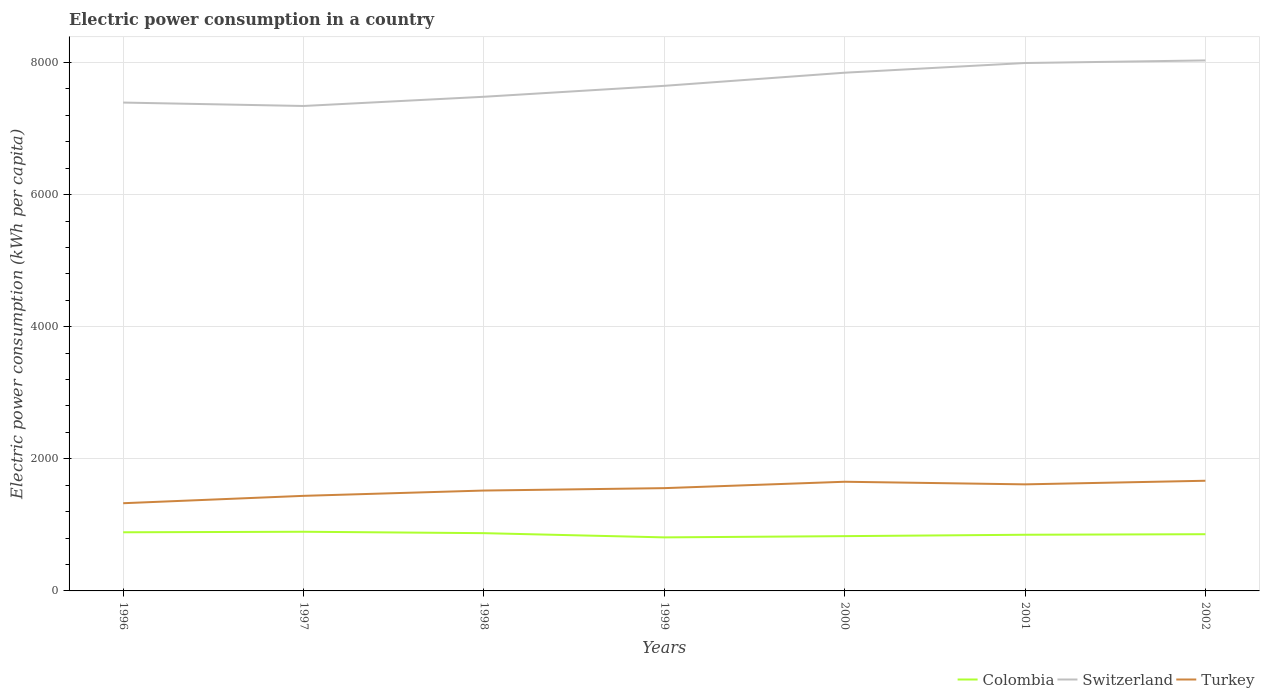How many different coloured lines are there?
Your answer should be compact. 3. Is the number of lines equal to the number of legend labels?
Your answer should be very brief. Yes. Across all years, what is the maximum electric power consumption in in Switzerland?
Provide a short and direct response. 7341.75. In which year was the electric power consumption in in Colombia maximum?
Provide a succinct answer. 1999. What is the total electric power consumption in in Switzerland in the graph?
Your response must be concise. -650.52. What is the difference between the highest and the second highest electric power consumption in in Colombia?
Provide a succinct answer. 85.18. What is the difference between the highest and the lowest electric power consumption in in Switzerland?
Your response must be concise. 3. How many lines are there?
Make the answer very short. 3. Are the values on the major ticks of Y-axis written in scientific E-notation?
Your answer should be very brief. No. How are the legend labels stacked?
Provide a succinct answer. Horizontal. What is the title of the graph?
Provide a succinct answer. Electric power consumption in a country. What is the label or title of the Y-axis?
Make the answer very short. Electric power consumption (kWh per capita). What is the Electric power consumption (kWh per capita) of Colombia in 1996?
Your response must be concise. 887.8. What is the Electric power consumption (kWh per capita) of Switzerland in 1996?
Make the answer very short. 7393.54. What is the Electric power consumption (kWh per capita) of Turkey in 1996?
Provide a succinct answer. 1327.72. What is the Electric power consumption (kWh per capita) of Colombia in 1997?
Make the answer very short. 895.86. What is the Electric power consumption (kWh per capita) of Switzerland in 1997?
Offer a very short reply. 7341.75. What is the Electric power consumption (kWh per capita) of Turkey in 1997?
Your answer should be very brief. 1439.46. What is the Electric power consumption (kWh per capita) in Colombia in 1998?
Your answer should be very brief. 874.44. What is the Electric power consumption (kWh per capita) of Switzerland in 1998?
Keep it short and to the point. 7481.29. What is the Electric power consumption (kWh per capita) of Turkey in 1998?
Your response must be concise. 1519.72. What is the Electric power consumption (kWh per capita) of Colombia in 1999?
Your answer should be very brief. 810.69. What is the Electric power consumption (kWh per capita) in Switzerland in 1999?
Provide a succinct answer. 7646.85. What is the Electric power consumption (kWh per capita) in Turkey in 1999?
Your answer should be compact. 1556.13. What is the Electric power consumption (kWh per capita) in Colombia in 2000?
Make the answer very short. 829.4. What is the Electric power consumption (kWh per capita) in Switzerland in 2000?
Ensure brevity in your answer.  7845.5. What is the Electric power consumption (kWh per capita) of Turkey in 2000?
Provide a short and direct response. 1652.75. What is the Electric power consumption (kWh per capita) of Colombia in 2001?
Make the answer very short. 850.43. What is the Electric power consumption (kWh per capita) in Switzerland in 2001?
Provide a succinct answer. 7992.28. What is the Electric power consumption (kWh per capita) of Turkey in 2001?
Keep it short and to the point. 1613.24. What is the Electric power consumption (kWh per capita) in Colombia in 2002?
Make the answer very short. 858.62. What is the Electric power consumption (kWh per capita) in Switzerland in 2002?
Provide a succinct answer. 8031.43. What is the Electric power consumption (kWh per capita) in Turkey in 2002?
Give a very brief answer. 1667.87. Across all years, what is the maximum Electric power consumption (kWh per capita) in Colombia?
Make the answer very short. 895.86. Across all years, what is the maximum Electric power consumption (kWh per capita) in Switzerland?
Keep it short and to the point. 8031.43. Across all years, what is the maximum Electric power consumption (kWh per capita) in Turkey?
Offer a terse response. 1667.87. Across all years, what is the minimum Electric power consumption (kWh per capita) of Colombia?
Your answer should be compact. 810.69. Across all years, what is the minimum Electric power consumption (kWh per capita) in Switzerland?
Your answer should be very brief. 7341.75. Across all years, what is the minimum Electric power consumption (kWh per capita) in Turkey?
Keep it short and to the point. 1327.72. What is the total Electric power consumption (kWh per capita) in Colombia in the graph?
Make the answer very short. 6007.24. What is the total Electric power consumption (kWh per capita) of Switzerland in the graph?
Your response must be concise. 5.37e+04. What is the total Electric power consumption (kWh per capita) of Turkey in the graph?
Your answer should be compact. 1.08e+04. What is the difference between the Electric power consumption (kWh per capita) of Colombia in 1996 and that in 1997?
Provide a succinct answer. -8.06. What is the difference between the Electric power consumption (kWh per capita) in Switzerland in 1996 and that in 1997?
Your response must be concise. 51.79. What is the difference between the Electric power consumption (kWh per capita) in Turkey in 1996 and that in 1997?
Ensure brevity in your answer.  -111.74. What is the difference between the Electric power consumption (kWh per capita) of Colombia in 1996 and that in 1998?
Give a very brief answer. 13.36. What is the difference between the Electric power consumption (kWh per capita) in Switzerland in 1996 and that in 1998?
Ensure brevity in your answer.  -87.75. What is the difference between the Electric power consumption (kWh per capita) in Turkey in 1996 and that in 1998?
Your answer should be compact. -192. What is the difference between the Electric power consumption (kWh per capita) of Colombia in 1996 and that in 1999?
Give a very brief answer. 77.11. What is the difference between the Electric power consumption (kWh per capita) of Switzerland in 1996 and that in 1999?
Your response must be concise. -253.31. What is the difference between the Electric power consumption (kWh per capita) of Turkey in 1996 and that in 1999?
Offer a very short reply. -228.41. What is the difference between the Electric power consumption (kWh per capita) in Colombia in 1996 and that in 2000?
Your answer should be very brief. 58.4. What is the difference between the Electric power consumption (kWh per capita) of Switzerland in 1996 and that in 2000?
Offer a very short reply. -451.96. What is the difference between the Electric power consumption (kWh per capita) in Turkey in 1996 and that in 2000?
Offer a very short reply. -325.03. What is the difference between the Electric power consumption (kWh per capita) in Colombia in 1996 and that in 2001?
Provide a succinct answer. 37.38. What is the difference between the Electric power consumption (kWh per capita) of Switzerland in 1996 and that in 2001?
Your answer should be very brief. -598.74. What is the difference between the Electric power consumption (kWh per capita) in Turkey in 1996 and that in 2001?
Provide a short and direct response. -285.52. What is the difference between the Electric power consumption (kWh per capita) in Colombia in 1996 and that in 2002?
Offer a very short reply. 29.18. What is the difference between the Electric power consumption (kWh per capita) in Switzerland in 1996 and that in 2002?
Make the answer very short. -637.89. What is the difference between the Electric power consumption (kWh per capita) in Turkey in 1996 and that in 2002?
Provide a short and direct response. -340.14. What is the difference between the Electric power consumption (kWh per capita) of Colombia in 1997 and that in 1998?
Offer a terse response. 21.42. What is the difference between the Electric power consumption (kWh per capita) in Switzerland in 1997 and that in 1998?
Your answer should be very brief. -139.54. What is the difference between the Electric power consumption (kWh per capita) of Turkey in 1997 and that in 1998?
Your answer should be very brief. -80.26. What is the difference between the Electric power consumption (kWh per capita) of Colombia in 1997 and that in 1999?
Your response must be concise. 85.18. What is the difference between the Electric power consumption (kWh per capita) in Switzerland in 1997 and that in 1999?
Provide a short and direct response. -305.09. What is the difference between the Electric power consumption (kWh per capita) of Turkey in 1997 and that in 1999?
Ensure brevity in your answer.  -116.67. What is the difference between the Electric power consumption (kWh per capita) in Colombia in 1997 and that in 2000?
Your answer should be very brief. 66.46. What is the difference between the Electric power consumption (kWh per capita) of Switzerland in 1997 and that in 2000?
Provide a short and direct response. -503.74. What is the difference between the Electric power consumption (kWh per capita) of Turkey in 1997 and that in 2000?
Provide a short and direct response. -213.29. What is the difference between the Electric power consumption (kWh per capita) in Colombia in 1997 and that in 2001?
Offer a very short reply. 45.44. What is the difference between the Electric power consumption (kWh per capita) of Switzerland in 1997 and that in 2001?
Keep it short and to the point. -650.52. What is the difference between the Electric power consumption (kWh per capita) in Turkey in 1997 and that in 2001?
Offer a very short reply. -173.78. What is the difference between the Electric power consumption (kWh per capita) of Colombia in 1997 and that in 2002?
Make the answer very short. 37.24. What is the difference between the Electric power consumption (kWh per capita) in Switzerland in 1997 and that in 2002?
Ensure brevity in your answer.  -689.68. What is the difference between the Electric power consumption (kWh per capita) of Turkey in 1997 and that in 2002?
Make the answer very short. -228.4. What is the difference between the Electric power consumption (kWh per capita) in Colombia in 1998 and that in 1999?
Make the answer very short. 63.76. What is the difference between the Electric power consumption (kWh per capita) in Switzerland in 1998 and that in 1999?
Make the answer very short. -165.55. What is the difference between the Electric power consumption (kWh per capita) in Turkey in 1998 and that in 1999?
Your response must be concise. -36.41. What is the difference between the Electric power consumption (kWh per capita) of Colombia in 1998 and that in 2000?
Give a very brief answer. 45.05. What is the difference between the Electric power consumption (kWh per capita) in Switzerland in 1998 and that in 2000?
Offer a terse response. -364.2. What is the difference between the Electric power consumption (kWh per capita) of Turkey in 1998 and that in 2000?
Your answer should be compact. -133.03. What is the difference between the Electric power consumption (kWh per capita) in Colombia in 1998 and that in 2001?
Keep it short and to the point. 24.02. What is the difference between the Electric power consumption (kWh per capita) of Switzerland in 1998 and that in 2001?
Offer a terse response. -510.98. What is the difference between the Electric power consumption (kWh per capita) in Turkey in 1998 and that in 2001?
Provide a succinct answer. -93.52. What is the difference between the Electric power consumption (kWh per capita) of Colombia in 1998 and that in 2002?
Your answer should be compact. 15.82. What is the difference between the Electric power consumption (kWh per capita) of Switzerland in 1998 and that in 2002?
Your response must be concise. -550.14. What is the difference between the Electric power consumption (kWh per capita) in Turkey in 1998 and that in 2002?
Your answer should be very brief. -148.15. What is the difference between the Electric power consumption (kWh per capita) in Colombia in 1999 and that in 2000?
Provide a short and direct response. -18.71. What is the difference between the Electric power consumption (kWh per capita) of Switzerland in 1999 and that in 2000?
Your answer should be very brief. -198.65. What is the difference between the Electric power consumption (kWh per capita) in Turkey in 1999 and that in 2000?
Give a very brief answer. -96.62. What is the difference between the Electric power consumption (kWh per capita) in Colombia in 1999 and that in 2001?
Provide a succinct answer. -39.74. What is the difference between the Electric power consumption (kWh per capita) of Switzerland in 1999 and that in 2001?
Your answer should be compact. -345.43. What is the difference between the Electric power consumption (kWh per capita) in Turkey in 1999 and that in 2001?
Offer a terse response. -57.11. What is the difference between the Electric power consumption (kWh per capita) in Colombia in 1999 and that in 2002?
Ensure brevity in your answer.  -47.93. What is the difference between the Electric power consumption (kWh per capita) of Switzerland in 1999 and that in 2002?
Make the answer very short. -384.59. What is the difference between the Electric power consumption (kWh per capita) in Turkey in 1999 and that in 2002?
Keep it short and to the point. -111.74. What is the difference between the Electric power consumption (kWh per capita) in Colombia in 2000 and that in 2001?
Give a very brief answer. -21.03. What is the difference between the Electric power consumption (kWh per capita) in Switzerland in 2000 and that in 2001?
Offer a terse response. -146.78. What is the difference between the Electric power consumption (kWh per capita) of Turkey in 2000 and that in 2001?
Offer a terse response. 39.51. What is the difference between the Electric power consumption (kWh per capita) in Colombia in 2000 and that in 2002?
Give a very brief answer. -29.22. What is the difference between the Electric power consumption (kWh per capita) in Switzerland in 2000 and that in 2002?
Keep it short and to the point. -185.94. What is the difference between the Electric power consumption (kWh per capita) of Turkey in 2000 and that in 2002?
Keep it short and to the point. -15.12. What is the difference between the Electric power consumption (kWh per capita) in Colombia in 2001 and that in 2002?
Keep it short and to the point. -8.2. What is the difference between the Electric power consumption (kWh per capita) of Switzerland in 2001 and that in 2002?
Ensure brevity in your answer.  -39.15. What is the difference between the Electric power consumption (kWh per capita) of Turkey in 2001 and that in 2002?
Your answer should be compact. -54.63. What is the difference between the Electric power consumption (kWh per capita) of Colombia in 1996 and the Electric power consumption (kWh per capita) of Switzerland in 1997?
Provide a succinct answer. -6453.95. What is the difference between the Electric power consumption (kWh per capita) of Colombia in 1996 and the Electric power consumption (kWh per capita) of Turkey in 1997?
Your response must be concise. -551.66. What is the difference between the Electric power consumption (kWh per capita) in Switzerland in 1996 and the Electric power consumption (kWh per capita) in Turkey in 1997?
Provide a succinct answer. 5954.08. What is the difference between the Electric power consumption (kWh per capita) in Colombia in 1996 and the Electric power consumption (kWh per capita) in Switzerland in 1998?
Offer a terse response. -6593.49. What is the difference between the Electric power consumption (kWh per capita) of Colombia in 1996 and the Electric power consumption (kWh per capita) of Turkey in 1998?
Give a very brief answer. -631.92. What is the difference between the Electric power consumption (kWh per capita) of Switzerland in 1996 and the Electric power consumption (kWh per capita) of Turkey in 1998?
Your response must be concise. 5873.82. What is the difference between the Electric power consumption (kWh per capita) in Colombia in 1996 and the Electric power consumption (kWh per capita) in Switzerland in 1999?
Provide a short and direct response. -6759.04. What is the difference between the Electric power consumption (kWh per capita) in Colombia in 1996 and the Electric power consumption (kWh per capita) in Turkey in 1999?
Your answer should be compact. -668.33. What is the difference between the Electric power consumption (kWh per capita) in Switzerland in 1996 and the Electric power consumption (kWh per capita) in Turkey in 1999?
Give a very brief answer. 5837.41. What is the difference between the Electric power consumption (kWh per capita) in Colombia in 1996 and the Electric power consumption (kWh per capita) in Switzerland in 2000?
Your answer should be very brief. -6957.69. What is the difference between the Electric power consumption (kWh per capita) in Colombia in 1996 and the Electric power consumption (kWh per capita) in Turkey in 2000?
Provide a succinct answer. -764.95. What is the difference between the Electric power consumption (kWh per capita) of Switzerland in 1996 and the Electric power consumption (kWh per capita) of Turkey in 2000?
Your answer should be very brief. 5740.79. What is the difference between the Electric power consumption (kWh per capita) of Colombia in 1996 and the Electric power consumption (kWh per capita) of Switzerland in 2001?
Give a very brief answer. -7104.48. What is the difference between the Electric power consumption (kWh per capita) in Colombia in 1996 and the Electric power consumption (kWh per capita) in Turkey in 2001?
Keep it short and to the point. -725.44. What is the difference between the Electric power consumption (kWh per capita) in Switzerland in 1996 and the Electric power consumption (kWh per capita) in Turkey in 2001?
Provide a succinct answer. 5780.3. What is the difference between the Electric power consumption (kWh per capita) in Colombia in 1996 and the Electric power consumption (kWh per capita) in Switzerland in 2002?
Provide a short and direct response. -7143.63. What is the difference between the Electric power consumption (kWh per capita) of Colombia in 1996 and the Electric power consumption (kWh per capita) of Turkey in 2002?
Your answer should be compact. -780.06. What is the difference between the Electric power consumption (kWh per capita) of Switzerland in 1996 and the Electric power consumption (kWh per capita) of Turkey in 2002?
Provide a short and direct response. 5725.67. What is the difference between the Electric power consumption (kWh per capita) in Colombia in 1997 and the Electric power consumption (kWh per capita) in Switzerland in 1998?
Keep it short and to the point. -6585.43. What is the difference between the Electric power consumption (kWh per capita) of Colombia in 1997 and the Electric power consumption (kWh per capita) of Turkey in 1998?
Your answer should be compact. -623.86. What is the difference between the Electric power consumption (kWh per capita) of Switzerland in 1997 and the Electric power consumption (kWh per capita) of Turkey in 1998?
Offer a very short reply. 5822.03. What is the difference between the Electric power consumption (kWh per capita) in Colombia in 1997 and the Electric power consumption (kWh per capita) in Switzerland in 1999?
Your answer should be compact. -6750.98. What is the difference between the Electric power consumption (kWh per capita) in Colombia in 1997 and the Electric power consumption (kWh per capita) in Turkey in 1999?
Offer a very short reply. -660.27. What is the difference between the Electric power consumption (kWh per capita) of Switzerland in 1997 and the Electric power consumption (kWh per capita) of Turkey in 1999?
Make the answer very short. 5785.62. What is the difference between the Electric power consumption (kWh per capita) in Colombia in 1997 and the Electric power consumption (kWh per capita) in Switzerland in 2000?
Your answer should be very brief. -6949.63. What is the difference between the Electric power consumption (kWh per capita) in Colombia in 1997 and the Electric power consumption (kWh per capita) in Turkey in 2000?
Offer a very short reply. -756.88. What is the difference between the Electric power consumption (kWh per capita) of Switzerland in 1997 and the Electric power consumption (kWh per capita) of Turkey in 2000?
Keep it short and to the point. 5689.01. What is the difference between the Electric power consumption (kWh per capita) in Colombia in 1997 and the Electric power consumption (kWh per capita) in Switzerland in 2001?
Your answer should be compact. -7096.41. What is the difference between the Electric power consumption (kWh per capita) of Colombia in 1997 and the Electric power consumption (kWh per capita) of Turkey in 2001?
Offer a terse response. -717.38. What is the difference between the Electric power consumption (kWh per capita) in Switzerland in 1997 and the Electric power consumption (kWh per capita) in Turkey in 2001?
Offer a very short reply. 5728.51. What is the difference between the Electric power consumption (kWh per capita) of Colombia in 1997 and the Electric power consumption (kWh per capita) of Switzerland in 2002?
Provide a succinct answer. -7135.57. What is the difference between the Electric power consumption (kWh per capita) in Colombia in 1997 and the Electric power consumption (kWh per capita) in Turkey in 2002?
Make the answer very short. -772. What is the difference between the Electric power consumption (kWh per capita) in Switzerland in 1997 and the Electric power consumption (kWh per capita) in Turkey in 2002?
Provide a succinct answer. 5673.89. What is the difference between the Electric power consumption (kWh per capita) in Colombia in 1998 and the Electric power consumption (kWh per capita) in Switzerland in 1999?
Offer a very short reply. -6772.4. What is the difference between the Electric power consumption (kWh per capita) of Colombia in 1998 and the Electric power consumption (kWh per capita) of Turkey in 1999?
Your answer should be very brief. -681.68. What is the difference between the Electric power consumption (kWh per capita) of Switzerland in 1998 and the Electric power consumption (kWh per capita) of Turkey in 1999?
Offer a very short reply. 5925.16. What is the difference between the Electric power consumption (kWh per capita) in Colombia in 1998 and the Electric power consumption (kWh per capita) in Switzerland in 2000?
Provide a succinct answer. -6971.05. What is the difference between the Electric power consumption (kWh per capita) in Colombia in 1998 and the Electric power consumption (kWh per capita) in Turkey in 2000?
Ensure brevity in your answer.  -778.3. What is the difference between the Electric power consumption (kWh per capita) of Switzerland in 1998 and the Electric power consumption (kWh per capita) of Turkey in 2000?
Your answer should be very brief. 5828.55. What is the difference between the Electric power consumption (kWh per capita) of Colombia in 1998 and the Electric power consumption (kWh per capita) of Switzerland in 2001?
Your answer should be compact. -7117.83. What is the difference between the Electric power consumption (kWh per capita) in Colombia in 1998 and the Electric power consumption (kWh per capita) in Turkey in 2001?
Make the answer very short. -738.79. What is the difference between the Electric power consumption (kWh per capita) in Switzerland in 1998 and the Electric power consumption (kWh per capita) in Turkey in 2001?
Provide a succinct answer. 5868.05. What is the difference between the Electric power consumption (kWh per capita) of Colombia in 1998 and the Electric power consumption (kWh per capita) of Switzerland in 2002?
Offer a very short reply. -7156.99. What is the difference between the Electric power consumption (kWh per capita) in Colombia in 1998 and the Electric power consumption (kWh per capita) in Turkey in 2002?
Ensure brevity in your answer.  -793.42. What is the difference between the Electric power consumption (kWh per capita) of Switzerland in 1998 and the Electric power consumption (kWh per capita) of Turkey in 2002?
Ensure brevity in your answer.  5813.43. What is the difference between the Electric power consumption (kWh per capita) in Colombia in 1999 and the Electric power consumption (kWh per capita) in Switzerland in 2000?
Give a very brief answer. -7034.81. What is the difference between the Electric power consumption (kWh per capita) of Colombia in 1999 and the Electric power consumption (kWh per capita) of Turkey in 2000?
Keep it short and to the point. -842.06. What is the difference between the Electric power consumption (kWh per capita) of Switzerland in 1999 and the Electric power consumption (kWh per capita) of Turkey in 2000?
Provide a succinct answer. 5994.1. What is the difference between the Electric power consumption (kWh per capita) of Colombia in 1999 and the Electric power consumption (kWh per capita) of Switzerland in 2001?
Provide a short and direct response. -7181.59. What is the difference between the Electric power consumption (kWh per capita) in Colombia in 1999 and the Electric power consumption (kWh per capita) in Turkey in 2001?
Provide a short and direct response. -802.55. What is the difference between the Electric power consumption (kWh per capita) of Switzerland in 1999 and the Electric power consumption (kWh per capita) of Turkey in 2001?
Keep it short and to the point. 6033.61. What is the difference between the Electric power consumption (kWh per capita) in Colombia in 1999 and the Electric power consumption (kWh per capita) in Switzerland in 2002?
Give a very brief answer. -7220.74. What is the difference between the Electric power consumption (kWh per capita) in Colombia in 1999 and the Electric power consumption (kWh per capita) in Turkey in 2002?
Provide a short and direct response. -857.18. What is the difference between the Electric power consumption (kWh per capita) in Switzerland in 1999 and the Electric power consumption (kWh per capita) in Turkey in 2002?
Give a very brief answer. 5978.98. What is the difference between the Electric power consumption (kWh per capita) of Colombia in 2000 and the Electric power consumption (kWh per capita) of Switzerland in 2001?
Provide a succinct answer. -7162.88. What is the difference between the Electric power consumption (kWh per capita) in Colombia in 2000 and the Electric power consumption (kWh per capita) in Turkey in 2001?
Ensure brevity in your answer.  -783.84. What is the difference between the Electric power consumption (kWh per capita) in Switzerland in 2000 and the Electric power consumption (kWh per capita) in Turkey in 2001?
Offer a very short reply. 6232.26. What is the difference between the Electric power consumption (kWh per capita) of Colombia in 2000 and the Electric power consumption (kWh per capita) of Switzerland in 2002?
Give a very brief answer. -7202.03. What is the difference between the Electric power consumption (kWh per capita) of Colombia in 2000 and the Electric power consumption (kWh per capita) of Turkey in 2002?
Provide a succinct answer. -838.47. What is the difference between the Electric power consumption (kWh per capita) in Switzerland in 2000 and the Electric power consumption (kWh per capita) in Turkey in 2002?
Offer a very short reply. 6177.63. What is the difference between the Electric power consumption (kWh per capita) of Colombia in 2001 and the Electric power consumption (kWh per capita) of Switzerland in 2002?
Provide a succinct answer. -7181.01. What is the difference between the Electric power consumption (kWh per capita) in Colombia in 2001 and the Electric power consumption (kWh per capita) in Turkey in 2002?
Provide a short and direct response. -817.44. What is the difference between the Electric power consumption (kWh per capita) in Switzerland in 2001 and the Electric power consumption (kWh per capita) in Turkey in 2002?
Provide a short and direct response. 6324.41. What is the average Electric power consumption (kWh per capita) of Colombia per year?
Your answer should be very brief. 858.18. What is the average Electric power consumption (kWh per capita) of Switzerland per year?
Your answer should be compact. 7676.09. What is the average Electric power consumption (kWh per capita) in Turkey per year?
Provide a short and direct response. 1539.55. In the year 1996, what is the difference between the Electric power consumption (kWh per capita) of Colombia and Electric power consumption (kWh per capita) of Switzerland?
Keep it short and to the point. -6505.74. In the year 1996, what is the difference between the Electric power consumption (kWh per capita) of Colombia and Electric power consumption (kWh per capita) of Turkey?
Provide a short and direct response. -439.92. In the year 1996, what is the difference between the Electric power consumption (kWh per capita) of Switzerland and Electric power consumption (kWh per capita) of Turkey?
Offer a terse response. 6065.82. In the year 1997, what is the difference between the Electric power consumption (kWh per capita) in Colombia and Electric power consumption (kWh per capita) in Switzerland?
Offer a terse response. -6445.89. In the year 1997, what is the difference between the Electric power consumption (kWh per capita) in Colombia and Electric power consumption (kWh per capita) in Turkey?
Provide a succinct answer. -543.6. In the year 1997, what is the difference between the Electric power consumption (kWh per capita) of Switzerland and Electric power consumption (kWh per capita) of Turkey?
Offer a terse response. 5902.29. In the year 1998, what is the difference between the Electric power consumption (kWh per capita) of Colombia and Electric power consumption (kWh per capita) of Switzerland?
Your answer should be compact. -6606.85. In the year 1998, what is the difference between the Electric power consumption (kWh per capita) in Colombia and Electric power consumption (kWh per capita) in Turkey?
Offer a terse response. -645.28. In the year 1998, what is the difference between the Electric power consumption (kWh per capita) of Switzerland and Electric power consumption (kWh per capita) of Turkey?
Ensure brevity in your answer.  5961.57. In the year 1999, what is the difference between the Electric power consumption (kWh per capita) in Colombia and Electric power consumption (kWh per capita) in Switzerland?
Your response must be concise. -6836.16. In the year 1999, what is the difference between the Electric power consumption (kWh per capita) in Colombia and Electric power consumption (kWh per capita) in Turkey?
Give a very brief answer. -745.44. In the year 1999, what is the difference between the Electric power consumption (kWh per capita) of Switzerland and Electric power consumption (kWh per capita) of Turkey?
Ensure brevity in your answer.  6090.72. In the year 2000, what is the difference between the Electric power consumption (kWh per capita) of Colombia and Electric power consumption (kWh per capita) of Switzerland?
Your answer should be very brief. -7016.1. In the year 2000, what is the difference between the Electric power consumption (kWh per capita) of Colombia and Electric power consumption (kWh per capita) of Turkey?
Provide a succinct answer. -823.35. In the year 2000, what is the difference between the Electric power consumption (kWh per capita) in Switzerland and Electric power consumption (kWh per capita) in Turkey?
Keep it short and to the point. 6192.75. In the year 2001, what is the difference between the Electric power consumption (kWh per capita) in Colombia and Electric power consumption (kWh per capita) in Switzerland?
Provide a short and direct response. -7141.85. In the year 2001, what is the difference between the Electric power consumption (kWh per capita) of Colombia and Electric power consumption (kWh per capita) of Turkey?
Keep it short and to the point. -762.81. In the year 2001, what is the difference between the Electric power consumption (kWh per capita) of Switzerland and Electric power consumption (kWh per capita) of Turkey?
Provide a succinct answer. 6379.04. In the year 2002, what is the difference between the Electric power consumption (kWh per capita) of Colombia and Electric power consumption (kWh per capita) of Switzerland?
Keep it short and to the point. -7172.81. In the year 2002, what is the difference between the Electric power consumption (kWh per capita) in Colombia and Electric power consumption (kWh per capita) in Turkey?
Make the answer very short. -809.24. In the year 2002, what is the difference between the Electric power consumption (kWh per capita) in Switzerland and Electric power consumption (kWh per capita) in Turkey?
Your answer should be very brief. 6363.57. What is the ratio of the Electric power consumption (kWh per capita) in Colombia in 1996 to that in 1997?
Provide a succinct answer. 0.99. What is the ratio of the Electric power consumption (kWh per capita) of Switzerland in 1996 to that in 1997?
Ensure brevity in your answer.  1.01. What is the ratio of the Electric power consumption (kWh per capita) in Turkey in 1996 to that in 1997?
Your answer should be compact. 0.92. What is the ratio of the Electric power consumption (kWh per capita) of Colombia in 1996 to that in 1998?
Your response must be concise. 1.02. What is the ratio of the Electric power consumption (kWh per capita) of Switzerland in 1996 to that in 1998?
Ensure brevity in your answer.  0.99. What is the ratio of the Electric power consumption (kWh per capita) of Turkey in 1996 to that in 1998?
Provide a succinct answer. 0.87. What is the ratio of the Electric power consumption (kWh per capita) in Colombia in 1996 to that in 1999?
Offer a terse response. 1.1. What is the ratio of the Electric power consumption (kWh per capita) in Switzerland in 1996 to that in 1999?
Give a very brief answer. 0.97. What is the ratio of the Electric power consumption (kWh per capita) of Turkey in 1996 to that in 1999?
Ensure brevity in your answer.  0.85. What is the ratio of the Electric power consumption (kWh per capita) in Colombia in 1996 to that in 2000?
Your answer should be compact. 1.07. What is the ratio of the Electric power consumption (kWh per capita) of Switzerland in 1996 to that in 2000?
Give a very brief answer. 0.94. What is the ratio of the Electric power consumption (kWh per capita) of Turkey in 1996 to that in 2000?
Ensure brevity in your answer.  0.8. What is the ratio of the Electric power consumption (kWh per capita) of Colombia in 1996 to that in 2001?
Your answer should be compact. 1.04. What is the ratio of the Electric power consumption (kWh per capita) of Switzerland in 1996 to that in 2001?
Provide a succinct answer. 0.93. What is the ratio of the Electric power consumption (kWh per capita) in Turkey in 1996 to that in 2001?
Keep it short and to the point. 0.82. What is the ratio of the Electric power consumption (kWh per capita) in Colombia in 1996 to that in 2002?
Offer a terse response. 1.03. What is the ratio of the Electric power consumption (kWh per capita) of Switzerland in 1996 to that in 2002?
Your answer should be very brief. 0.92. What is the ratio of the Electric power consumption (kWh per capita) of Turkey in 1996 to that in 2002?
Provide a succinct answer. 0.8. What is the ratio of the Electric power consumption (kWh per capita) in Colombia in 1997 to that in 1998?
Your answer should be compact. 1.02. What is the ratio of the Electric power consumption (kWh per capita) in Switzerland in 1997 to that in 1998?
Your answer should be compact. 0.98. What is the ratio of the Electric power consumption (kWh per capita) of Turkey in 1997 to that in 1998?
Ensure brevity in your answer.  0.95. What is the ratio of the Electric power consumption (kWh per capita) of Colombia in 1997 to that in 1999?
Give a very brief answer. 1.11. What is the ratio of the Electric power consumption (kWh per capita) of Switzerland in 1997 to that in 1999?
Offer a very short reply. 0.96. What is the ratio of the Electric power consumption (kWh per capita) in Turkey in 1997 to that in 1999?
Make the answer very short. 0.93. What is the ratio of the Electric power consumption (kWh per capita) of Colombia in 1997 to that in 2000?
Provide a short and direct response. 1.08. What is the ratio of the Electric power consumption (kWh per capita) in Switzerland in 1997 to that in 2000?
Make the answer very short. 0.94. What is the ratio of the Electric power consumption (kWh per capita) of Turkey in 1997 to that in 2000?
Give a very brief answer. 0.87. What is the ratio of the Electric power consumption (kWh per capita) of Colombia in 1997 to that in 2001?
Your response must be concise. 1.05. What is the ratio of the Electric power consumption (kWh per capita) of Switzerland in 1997 to that in 2001?
Ensure brevity in your answer.  0.92. What is the ratio of the Electric power consumption (kWh per capita) of Turkey in 1997 to that in 2001?
Your answer should be compact. 0.89. What is the ratio of the Electric power consumption (kWh per capita) of Colombia in 1997 to that in 2002?
Make the answer very short. 1.04. What is the ratio of the Electric power consumption (kWh per capita) of Switzerland in 1997 to that in 2002?
Your answer should be very brief. 0.91. What is the ratio of the Electric power consumption (kWh per capita) in Turkey in 1997 to that in 2002?
Make the answer very short. 0.86. What is the ratio of the Electric power consumption (kWh per capita) of Colombia in 1998 to that in 1999?
Keep it short and to the point. 1.08. What is the ratio of the Electric power consumption (kWh per capita) of Switzerland in 1998 to that in 1999?
Offer a very short reply. 0.98. What is the ratio of the Electric power consumption (kWh per capita) in Turkey in 1998 to that in 1999?
Your answer should be very brief. 0.98. What is the ratio of the Electric power consumption (kWh per capita) in Colombia in 1998 to that in 2000?
Provide a short and direct response. 1.05. What is the ratio of the Electric power consumption (kWh per capita) in Switzerland in 1998 to that in 2000?
Provide a short and direct response. 0.95. What is the ratio of the Electric power consumption (kWh per capita) of Turkey in 1998 to that in 2000?
Give a very brief answer. 0.92. What is the ratio of the Electric power consumption (kWh per capita) in Colombia in 1998 to that in 2001?
Your answer should be very brief. 1.03. What is the ratio of the Electric power consumption (kWh per capita) of Switzerland in 1998 to that in 2001?
Make the answer very short. 0.94. What is the ratio of the Electric power consumption (kWh per capita) in Turkey in 1998 to that in 2001?
Provide a succinct answer. 0.94. What is the ratio of the Electric power consumption (kWh per capita) of Colombia in 1998 to that in 2002?
Your answer should be very brief. 1.02. What is the ratio of the Electric power consumption (kWh per capita) of Switzerland in 1998 to that in 2002?
Offer a very short reply. 0.93. What is the ratio of the Electric power consumption (kWh per capita) of Turkey in 1998 to that in 2002?
Give a very brief answer. 0.91. What is the ratio of the Electric power consumption (kWh per capita) of Colombia in 1999 to that in 2000?
Ensure brevity in your answer.  0.98. What is the ratio of the Electric power consumption (kWh per capita) of Switzerland in 1999 to that in 2000?
Provide a short and direct response. 0.97. What is the ratio of the Electric power consumption (kWh per capita) of Turkey in 1999 to that in 2000?
Give a very brief answer. 0.94. What is the ratio of the Electric power consumption (kWh per capita) of Colombia in 1999 to that in 2001?
Keep it short and to the point. 0.95. What is the ratio of the Electric power consumption (kWh per capita) in Switzerland in 1999 to that in 2001?
Offer a very short reply. 0.96. What is the ratio of the Electric power consumption (kWh per capita) in Turkey in 1999 to that in 2001?
Make the answer very short. 0.96. What is the ratio of the Electric power consumption (kWh per capita) in Colombia in 1999 to that in 2002?
Make the answer very short. 0.94. What is the ratio of the Electric power consumption (kWh per capita) in Switzerland in 1999 to that in 2002?
Ensure brevity in your answer.  0.95. What is the ratio of the Electric power consumption (kWh per capita) in Turkey in 1999 to that in 2002?
Offer a terse response. 0.93. What is the ratio of the Electric power consumption (kWh per capita) in Colombia in 2000 to that in 2001?
Your answer should be very brief. 0.98. What is the ratio of the Electric power consumption (kWh per capita) in Switzerland in 2000 to that in 2001?
Give a very brief answer. 0.98. What is the ratio of the Electric power consumption (kWh per capita) of Turkey in 2000 to that in 2001?
Provide a short and direct response. 1.02. What is the ratio of the Electric power consumption (kWh per capita) of Colombia in 2000 to that in 2002?
Give a very brief answer. 0.97. What is the ratio of the Electric power consumption (kWh per capita) of Switzerland in 2000 to that in 2002?
Keep it short and to the point. 0.98. What is the ratio of the Electric power consumption (kWh per capita) of Turkey in 2000 to that in 2002?
Offer a very short reply. 0.99. What is the ratio of the Electric power consumption (kWh per capita) in Colombia in 2001 to that in 2002?
Your answer should be compact. 0.99. What is the ratio of the Electric power consumption (kWh per capita) in Turkey in 2001 to that in 2002?
Offer a terse response. 0.97. What is the difference between the highest and the second highest Electric power consumption (kWh per capita) in Colombia?
Your response must be concise. 8.06. What is the difference between the highest and the second highest Electric power consumption (kWh per capita) of Switzerland?
Offer a very short reply. 39.15. What is the difference between the highest and the second highest Electric power consumption (kWh per capita) of Turkey?
Offer a very short reply. 15.12. What is the difference between the highest and the lowest Electric power consumption (kWh per capita) in Colombia?
Keep it short and to the point. 85.18. What is the difference between the highest and the lowest Electric power consumption (kWh per capita) in Switzerland?
Provide a succinct answer. 689.68. What is the difference between the highest and the lowest Electric power consumption (kWh per capita) of Turkey?
Offer a very short reply. 340.14. 